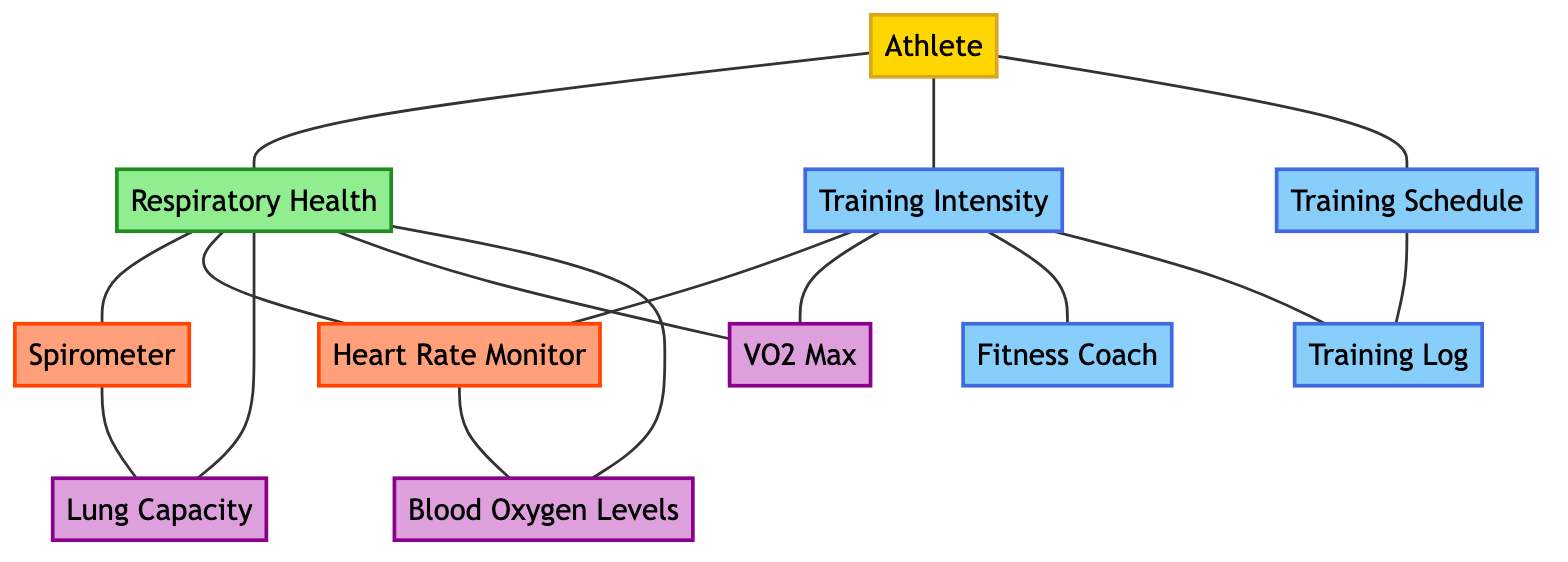What is the total number of nodes in the diagram? To find the total number of nodes, we can count them in the provided data under the "nodes" section. There are 11 nodes listed, each representing a different aspect of the respiratory health monitoring system.
Answer: 11 Which node is directly connected to the "Athlete"? We can check the "edges" section to see which nodes have edges that start from node 1 ("Athlete"). The connected nodes are "Respiratory Health", "Training Intensity", and "Training Schedule".
Answer: Respiratory Health, Training Intensity, Training Schedule What is the connection between "Training Intensity" and "Heart Rate Monitor"? To answer this, we need to see if there is a direct edge between "Training Intensity" (node 3) and "Heart Rate Monitor" (node 5) in the "edges" section. There is no direct connection listed, indicating they are not directly linked.
Answer: No direct connection How many nodes are connected to "Respiratory Health"? We look at how many edges connect to the "Respiratory Health" node (node 2). It is connected to "Spirometer", "Heart Rate Monitor", "Lung Capacity", "VO2 Max", and "Blood Oxygen Levels", making a total of five connections.
Answer: 5 What is the relationship between "Training Schedule" and "Training Log"? We check for a direct connection in the "edges" section. The "Training Schedule" node (node 7) is connected to the "Training Log" node (node 11), indicating a relationship exists between them.
Answer: Connected Which monitoring tools are connected to "Respiratory Health"? We can review the edges connected to "Respiratory Health" (node 2). The tools connected are "Spirometer" (node 4) and "Heart Rate Monitor" (node 5), indicating they are both used for monitoring in relation to respiratory health.
Answer: Spirometer, Heart Rate Monitor Is "Lung Capacity" connected to "Training Intensity"? To determine this, we can look at the edges to see if there is a direct connection from "Lung Capacity" (node 6) to "Training Intensity" (node 3). There is no edge listed between them, indicating no direct connection.
Answer: No direct connection What aspect of training is linked to "Fitness Coach"? We check the edges to see how "Fitness Coach" (node 10) is represented in the graph. It is connected directly to "Training Intensity" (node 3), linking that aspect of training to the fitness coach's role.
Answer: Training Intensity 